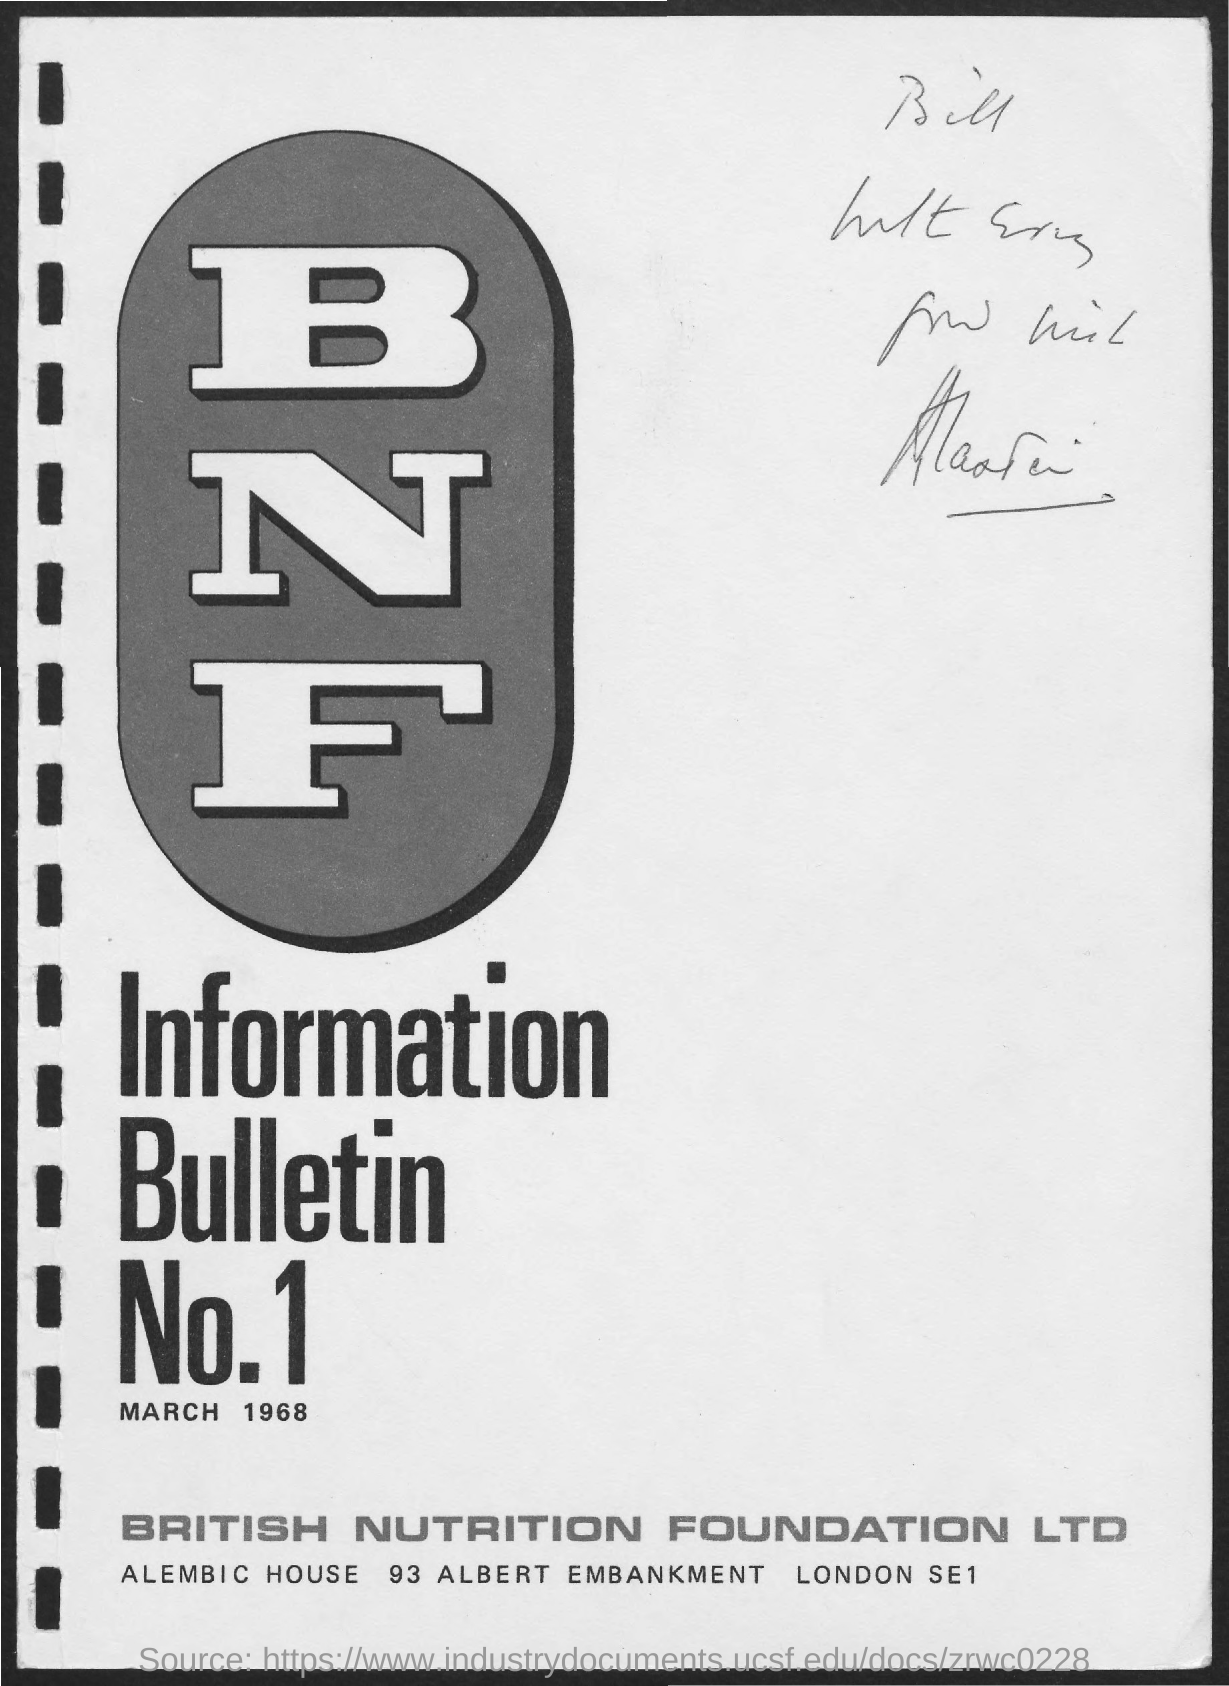Draw attention to some important aspects in this diagram. The date mentioned in the document is March 1968. 